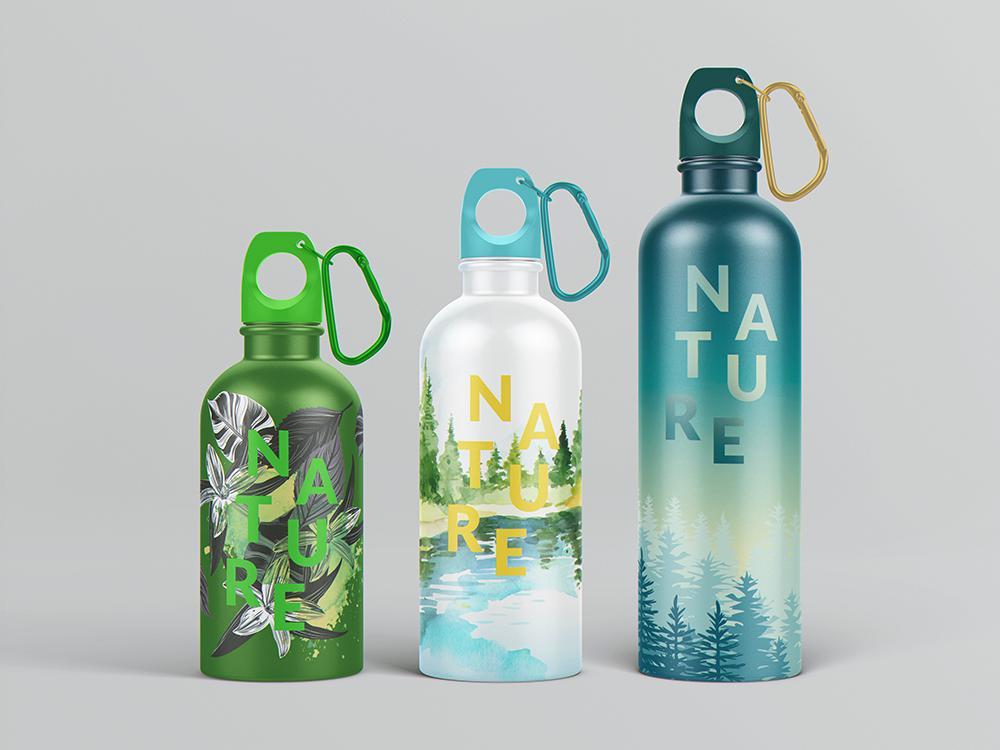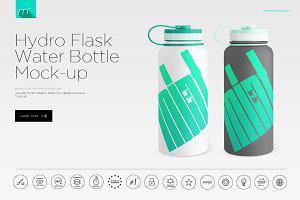The first image is the image on the left, the second image is the image on the right. Considering the images on both sides, is "The left image contains no more than one bottle." valid? Answer yes or no. No. The first image is the image on the left, the second image is the image on the right. Examine the images to the left and right. Is the description "Three bottles are grouped together in the image on the left." accurate? Answer yes or no. Yes. 